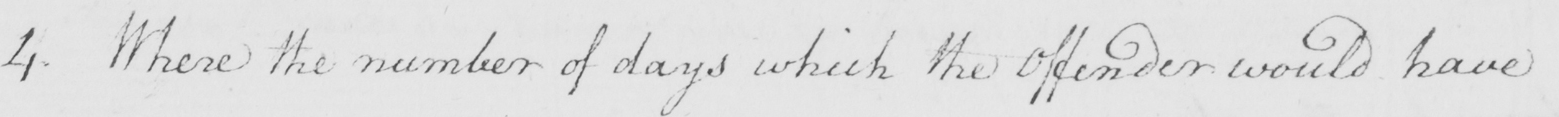Please transcribe the handwritten text in this image. 4 . Where the number of days which the Offender would have 